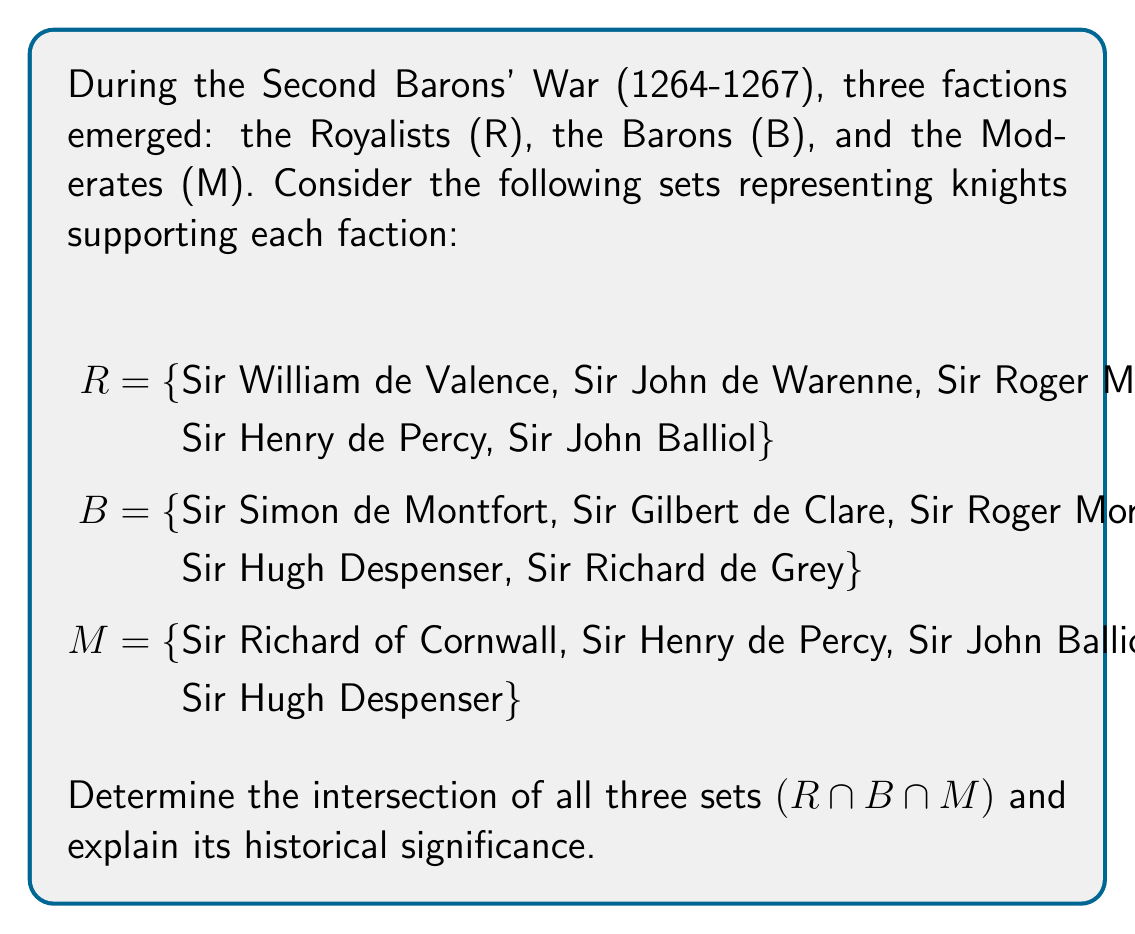Solve this math problem. To find the intersection of all three sets, we need to identify the elements that are common to all sets. Let's approach this step-by-step:

1) First, let's find the intersection of R and B:
   R ∩ B = {Sir Roger Mortimer}

2) Now, let's find the intersection of this result with M:
   (R ∩ B) ∩ M = {Sir Roger Mortimer} ∩ M

3) We can see that Sir Roger Mortimer is not in set M, so:
   R ∩ B ∩ M = ∅ (the empty set)

4) To verify, let's check each element in M against R and B:
   - Sir Richard of Cornwall: Not in R or B
   - Sir Henry de Percy: In R, not in B
   - Sir John Balliol: In R, not in B
   - Sir Hugh Despenser: In B, not in R

5) This confirms that there are no elements common to all three sets.

Historical significance:
The empty intersection suggests that during this tumultuous period, there were no knights who openly supported all three factions simultaneously. This reflects the intense political divisions of the time and the pressure on nobles to choose sides. It also highlights the complexity of medieval politics, where allegiances were often clear-cut and shifting between factions was risky.

The presence of some knights in two sets (e.g., Sir Henry de Percy in R and M, Sir Hugh Despenser in B and M) indicates that some individuals tried to balance their loyalties or changed allegiances during the conflict, which was not uncommon in medieval power struggles.
Answer: ∅ 